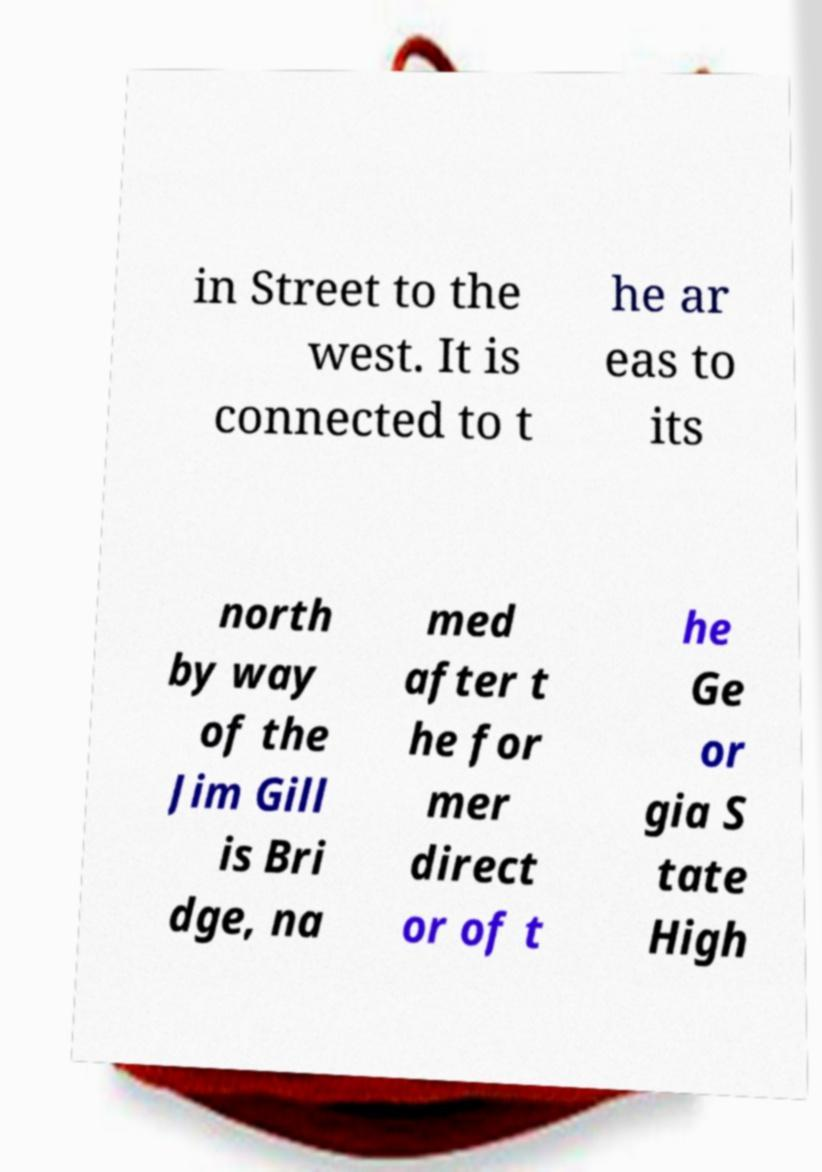Can you read and provide the text displayed in the image?This photo seems to have some interesting text. Can you extract and type it out for me? in Street to the west. It is connected to t he ar eas to its north by way of the Jim Gill is Bri dge, na med after t he for mer direct or of t he Ge or gia S tate High 